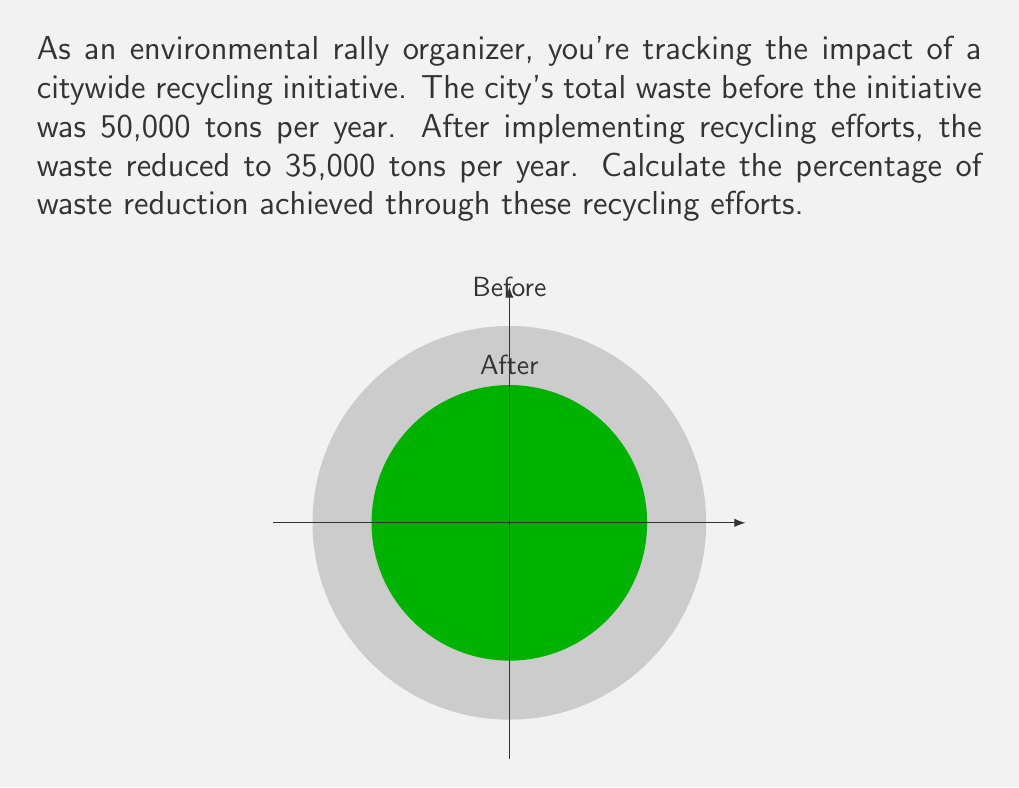Teach me how to tackle this problem. Let's approach this step-by-step:

1) First, let's identify our known values:
   - Initial waste: 50,000 tons
   - Waste after recycling: 35,000 tons

2) To calculate the percentage reduction, we need to:
   a) Find the amount of waste reduced
   b) Divide this by the initial amount
   c) Multiply by 100 to get the percentage

3) Amount of waste reduced:
   $$ \text{Waste reduced} = 50,000 - 35,000 = 15,000 \text{ tons} $$

4) Express this as a fraction of the initial amount:
   $$ \frac{\text{Waste reduced}}{\text{Initial waste}} = \frac{15,000}{50,000} = 0.3 $$

5) Convert to a percentage by multiplying by 100:
   $$ 0.3 \times 100 = 30\% $$

Therefore, the recycling efforts achieved a 30% reduction in waste.
Answer: 30% 